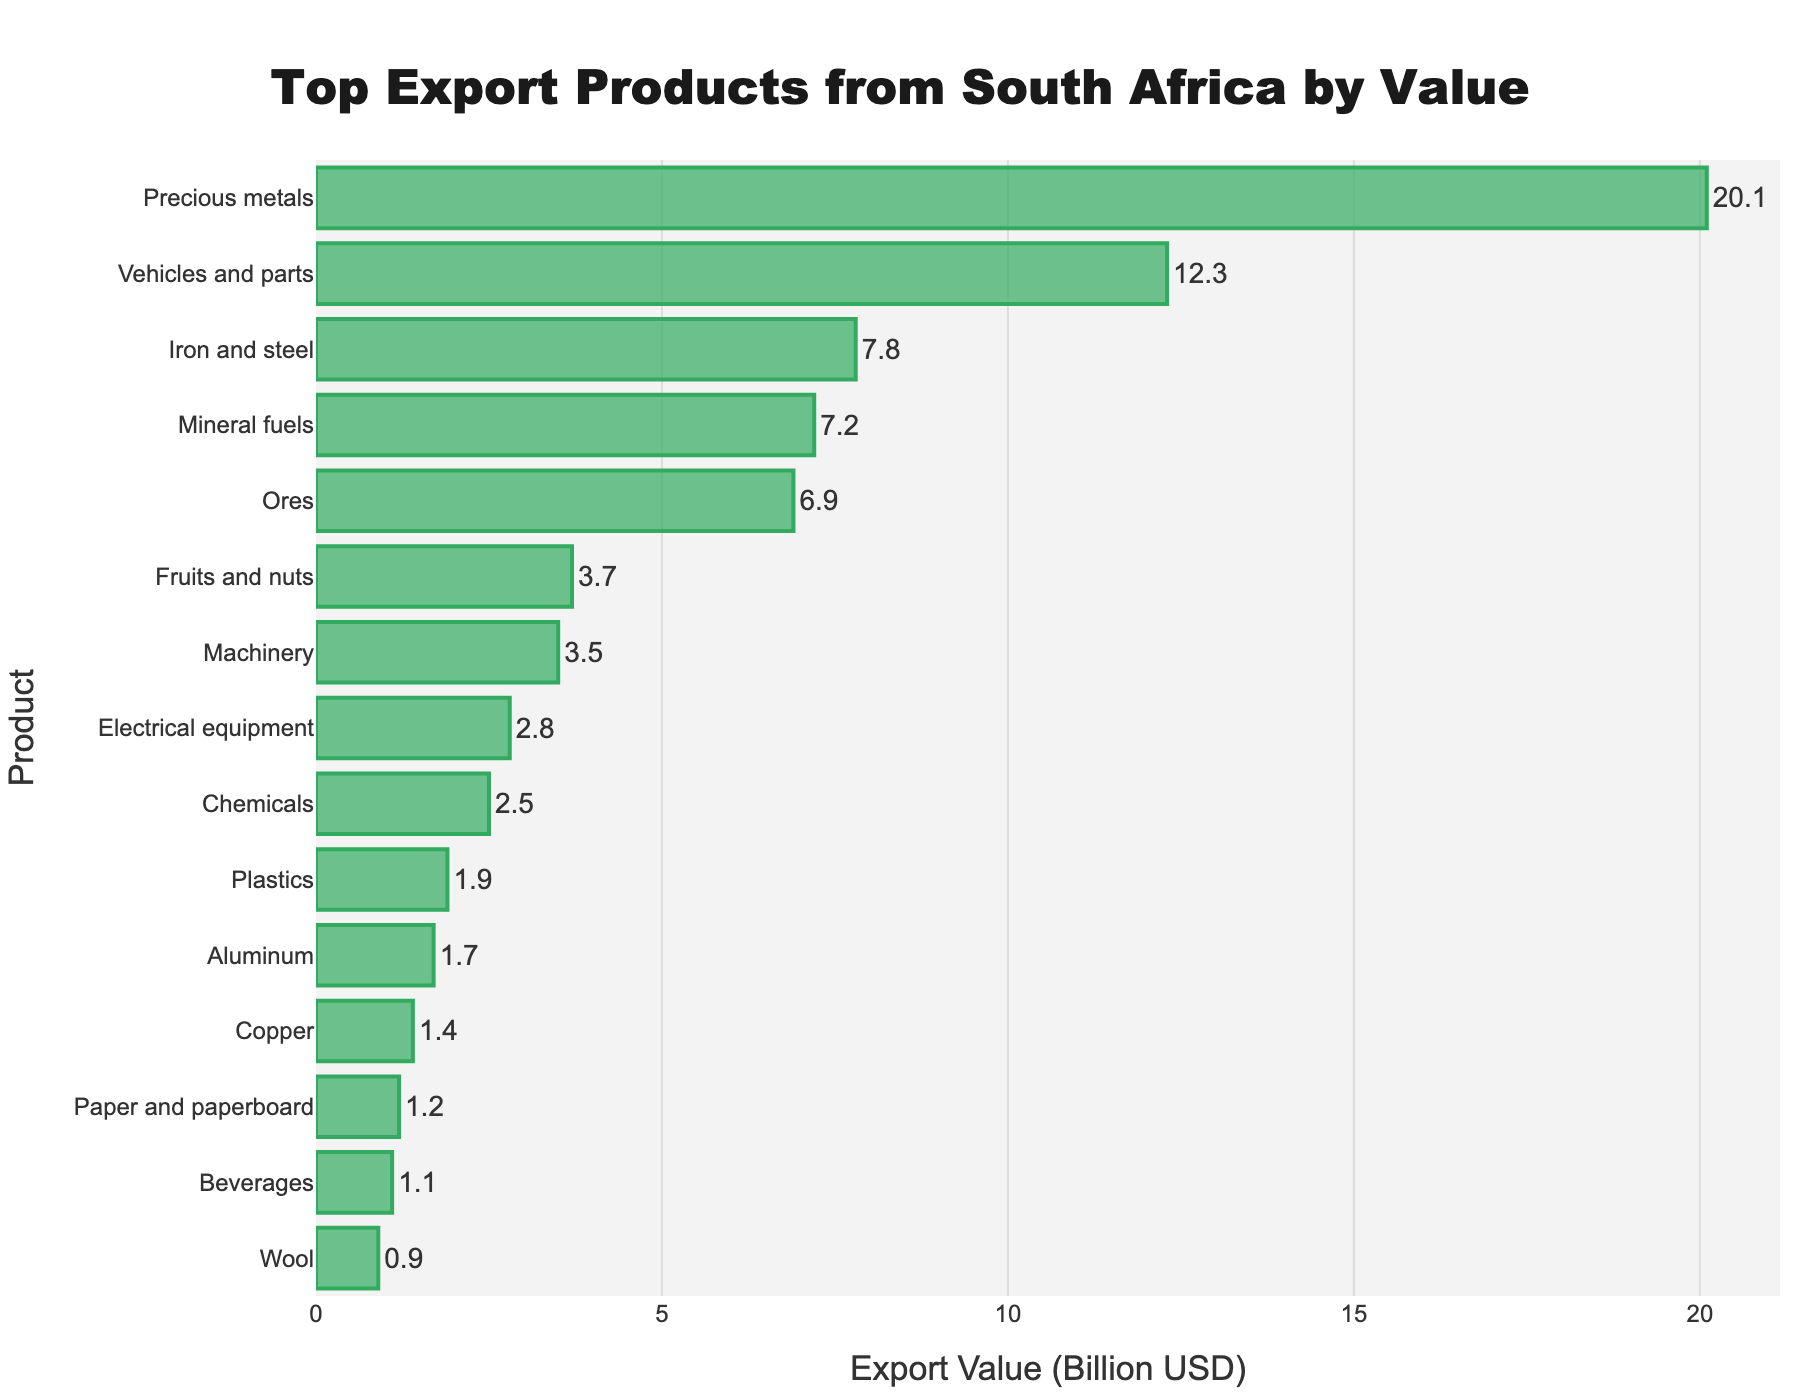what is the difference in export value between Precious metals and Vehicles and parts? To find the difference, identify the export values of Precious metals (20.1 billion USD) and Vehicles and parts (12.3 billion USD). Subtract the smaller value from the larger one: 20.1 - 12.3 = 7.8 billion USD.
Answer: 7.8 billion USD Which product has a higher export value: Machinery or Electrical equipment? By how much? First, find the export values of Machinery (3.5 billion USD) and Electrical equipment (2.8 billion USD). Subtract the smaller value from the larger one: 3.5 - 2.8 = 0.7 billion USD. Thus, Machinery has a higher export value by 0.7 billion USD.
Answer: Machinery by 0.7 billion USD How do the export values of Iron and steel and Mineral fuels compare? Compare the export values of Iron and steel (7.8 billion USD) and Mineral fuels (7.2 billion USD). Iron and steel have a higher export value than Mineral fuels.
Answer: Iron and steel has a higher export value What is the total export value of Fruits and nuts, Beverages, and Wool? Add the export values of Fruits and nuts (3.7 billion USD), Beverages (1.1 billion USD), and Wool (0.9 billion USD): 3.7 + 1.1 + 0.9 = 5.7 billion USD.
Answer: 5.7 billion USD Which product has the lowest export value, and what is it? The product with the lowest export value is Wool, with an export value of 0.9 billion USD.
Answer: Wool, 0.9 billion USD What is the combined export value of the three products with the highest export values? Identify the three products with the highest export values: Precious metals (20.1 billion USD), Vehicles and parts (12.3 billion USD), and Iron and steel (7.8 billion USD). Add these values: 20.1 + 12.3 + 7.8 = 40.2 billion USD.
Answer: 40.2 billion USD Which product's export value is closest to 2 billion USD? Compare the export values near 2 billion USD: Plastics (1.9 billion USD) and Electrical equipment (2.8 billion USD). The closest to 2 billion USD is Plastics.
Answer: Plastics Is the export value of Aluminum greater than Copper? Compare the export values of Aluminum (1.7 billion USD) and Copper (1.4 billion USD). Aluminum has a greater export value than Copper.
Answer: Yes How many products have an export value less than 5 billion USD? Identify the products with export values less than 5 billion USD: Fruits and nuts (3.7 billion USD), Machinery (3.5 billion USD), Electrical equipment (2.8 billion USD), Chemicals (2.5 billion USD), Plastics (1.9 billion USD), Aluminum (1.7 billion USD), Copper (1.4 billion USD), Paper and paperboard (1.2 billion USD), Beverages (1.1 billion USD), and Wool (0.9 billion USD). There are 10 such products.
Answer: 10 